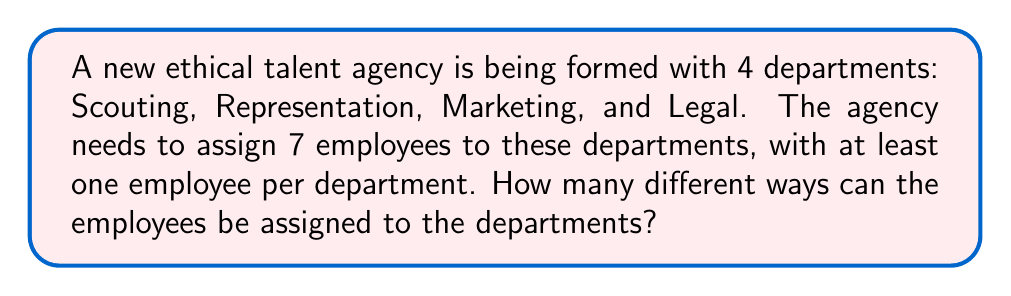Solve this math problem. Let's approach this step-by-step using the concept of distributions and Stirling numbers of the second kind:

1) This is a problem of distributing 7 distinct objects (employees) into 4 non-empty distinct boxes (departments).

2) We can use Stirling numbers of the second kind, denoted as $\stirling{n}{k}$, which represent the number of ways to partition a set of $n$ objects into $k$ non-empty subsets.

3) In this case, we need to consider all possible partitions of 7 employees into 4 departments:
   $$\stirling{7}{4}$$

4) To calculate this, we can use the formula:
   $$\stirling{n}{k} = \frac{1}{k!}\sum_{i=0}^k (-1)^i \binom{k}{i}(k-i)^n$$

5) Plugging in our values:
   $$\stirling{7}{4} = \frac{1}{4!}\sum_{i=0}^4 (-1)^i \binom{4}{i}(4-i)^7$$

6) Expanding this:
   $$\begin{align*}
   \stirling{7}{4} &= \frac{1}{24}[(1)(4^7) - (4)(3^7) + (6)(2^7) - (4)(1^7)]\\
   &= \frac{1}{24}[16384 - 8748 + 768 - 4]\\
   &= \frac{8400}{24}\\
   &= 350
   \end{align*}$$

7) However, this only gives us the number of ways to partition the employees. To get the total number of assignments, we need to multiply this by the number of ways to permute the departments, which is 4!.

8) Therefore, the final answer is:
   $$350 \times 4! = 350 \times 24 = 8400$$
Answer: 8400 